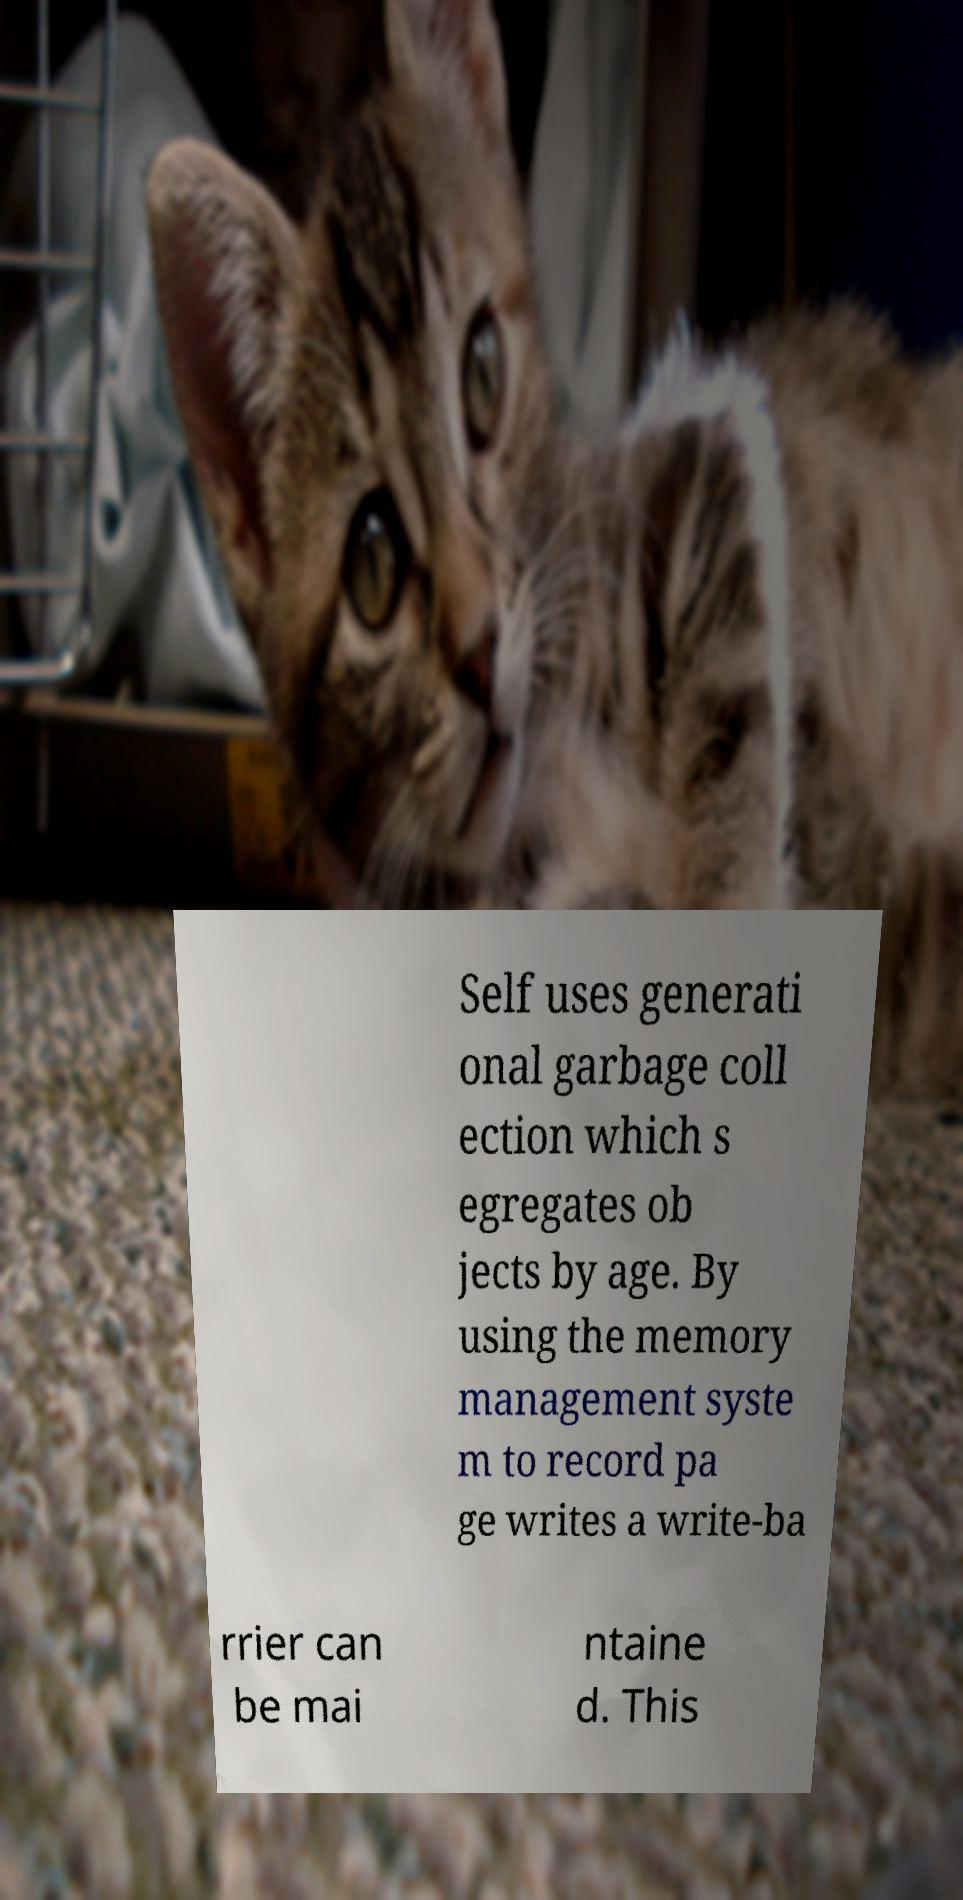I need the written content from this picture converted into text. Can you do that? Self uses generati onal garbage coll ection which s egregates ob jects by age. By using the memory management syste m to record pa ge writes a write-ba rrier can be mai ntaine d. This 